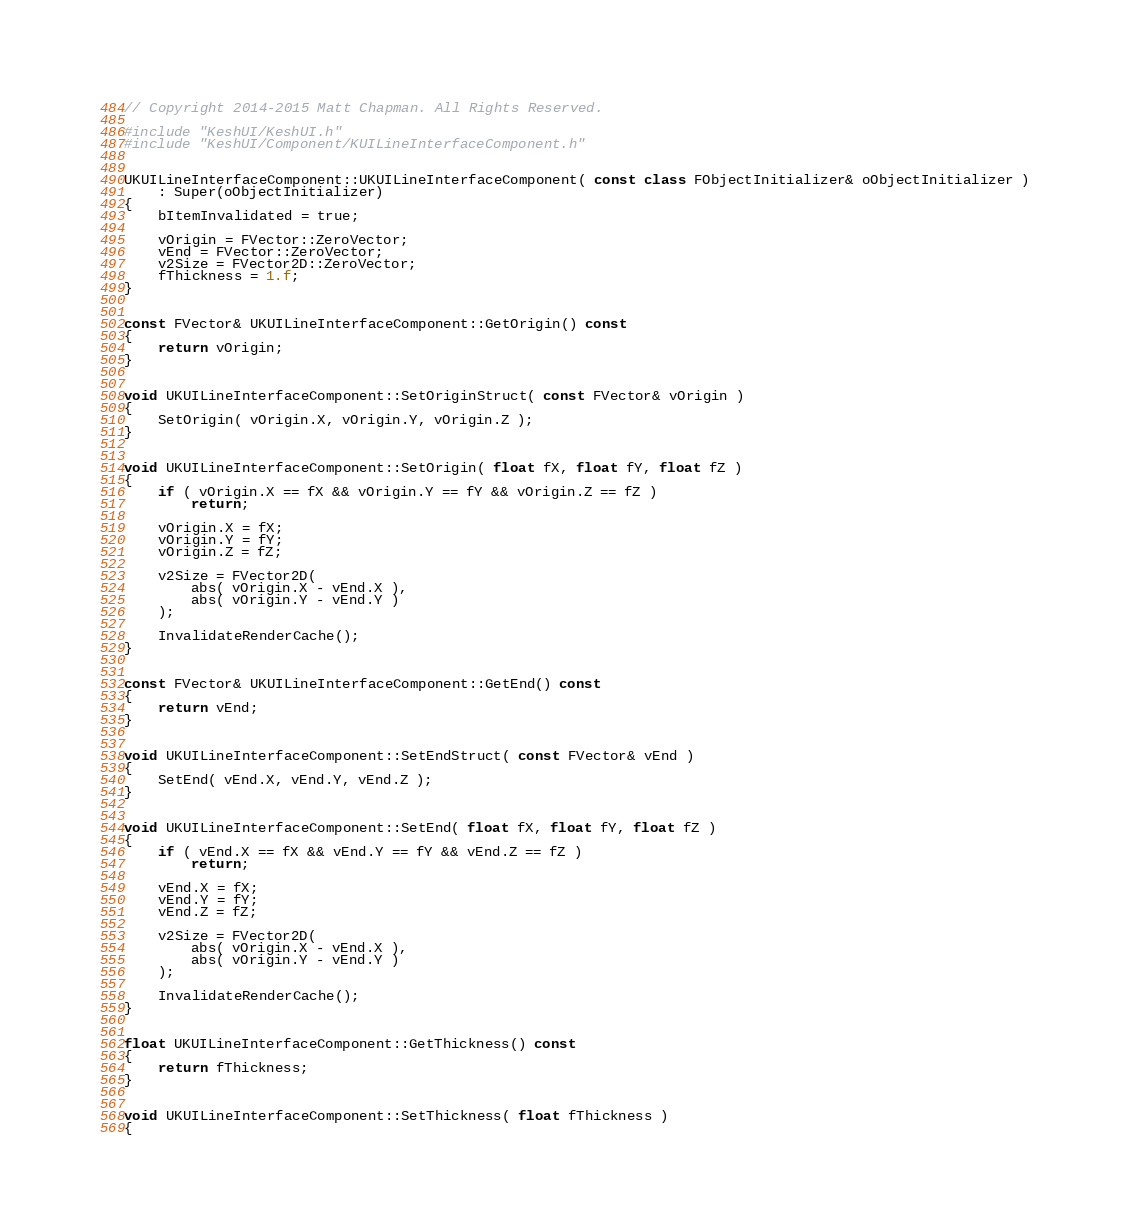<code> <loc_0><loc_0><loc_500><loc_500><_C++_>// Copyright 2014-2015 Matt Chapman. All Rights Reserved.

#include "KeshUI/KeshUI.h"
#include "KeshUI/Component/KUILineInterfaceComponent.h"


UKUILineInterfaceComponent::UKUILineInterfaceComponent( const class FObjectInitializer& oObjectInitializer )
	: Super(oObjectInitializer)
{
	bItemInvalidated = true;
	
	vOrigin = FVector::ZeroVector;
	vEnd = FVector::ZeroVector;
	v2Size = FVector2D::ZeroVector;
	fThickness = 1.f;
}


const FVector& UKUILineInterfaceComponent::GetOrigin() const
{
	return vOrigin;
}


void UKUILineInterfaceComponent::SetOriginStruct( const FVector& vOrigin )
{
	SetOrigin( vOrigin.X, vOrigin.Y, vOrigin.Z );
}


void UKUILineInterfaceComponent::SetOrigin( float fX, float fY, float fZ )
{
	if ( vOrigin.X == fX && vOrigin.Y == fY && vOrigin.Z == fZ )
		return;

	vOrigin.X = fX;
	vOrigin.Y = fY;
	vOrigin.Z = fZ;

	v2Size = FVector2D(
		abs( vOrigin.X - vEnd.X ),
		abs( vOrigin.Y - vEnd.Y )
	);

	InvalidateRenderCache();
}


const FVector& UKUILineInterfaceComponent::GetEnd() const
{
	return vEnd;
}


void UKUILineInterfaceComponent::SetEndStruct( const FVector& vEnd )
{
	SetEnd( vEnd.X, vEnd.Y, vEnd.Z );
}


void UKUILineInterfaceComponent::SetEnd( float fX, float fY, float fZ )
{
	if ( vEnd.X == fX && vEnd.Y == fY && vEnd.Z == fZ )
		return;

	vEnd.X = fX;
	vEnd.Y = fY;
	vEnd.Z = fZ;

	v2Size = FVector2D(
		abs( vOrigin.X - vEnd.X ),
		abs( vOrigin.Y - vEnd.Y )
	);

	InvalidateRenderCache();
}


float UKUILineInterfaceComponent::GetThickness() const
{
	return fThickness;
}


void UKUILineInterfaceComponent::SetThickness( float fThickness )
{</code> 